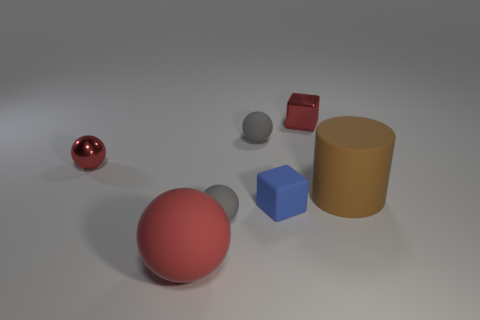Subtract 1 spheres. How many spheres are left? 3 Add 2 big red matte objects. How many objects exist? 9 Subtract all cylinders. How many objects are left? 6 Subtract 1 blue cubes. How many objects are left? 6 Subtract all matte things. Subtract all rubber cylinders. How many objects are left? 1 Add 1 tiny rubber balls. How many tiny rubber balls are left? 3 Add 1 small metal things. How many small metal things exist? 3 